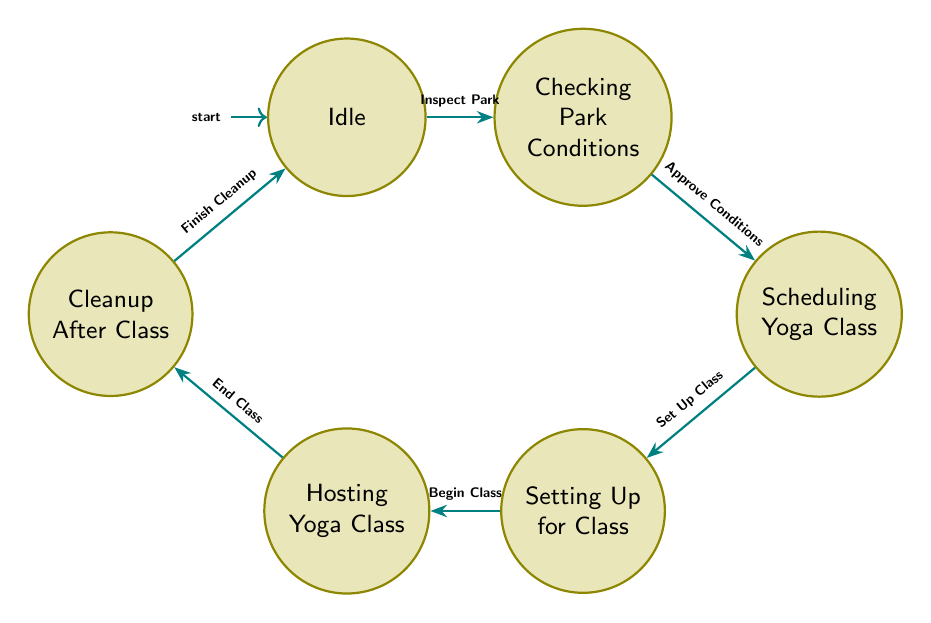What is the initial state of the diagram? The initial state is represented by the node labeled "Idle", which shows that no action is currently being taken.
Answer: Idle How many states are present in the diagram? By counting the distinct nodes within the diagram, we identify six states: Idle, Checking Park Conditions, Scheduling Yoga Class, Setting Up for Class, Hosting Yoga Class, and Cleanup After Class.
Answer: 6 What transition occurs after "Scheduling Yoga Class"? In the flow of the diagram, once the "Scheduling Yoga Class" state is completed, it transitions to the "Setting Up for Class" state, signifying the next step in the process.
Answer: Setting Up for Class Which state transitions to "Cleanup After Class"? The "Hosting Yoga Class" state directly transitions to "Cleanup After Class" once the yoga class has ended, indicating the cleanup process begins after class completion.
Answer: Hosting Yoga Class What is the last state in the sequence before returning to "Idle"? The last state before returning to "Idle" is "Cleanup After Class", as this state signifies the conclusion of the class activities and the return to the initial state.
Answer: Cleanup After Class What action transitions the diagram from "Checking Park Conditions" to "Scheduling Yoga Class"? The action that facilitates the transition from "Checking Park Conditions" to "Scheduling Yoga Class" is "Approve Conditions", meaning the conditions must be satisfactory before scheduling can occur.
Answer: Approve Conditions If you start at "Idle", which state do you reach first? Starting at "Idle", the first transition leads to "Checking Park Conditions" upon performing the action "Inspect Park".
Answer: Checking Park Conditions What is the total number of transitions in the diagram? Counting the directed edges between the states, there are a total of six transitions outlined within the diagram, illustrating the process flow.
Answer: 6 